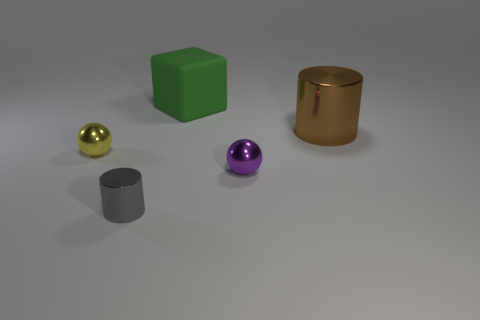Add 3 large yellow balls. How many objects exist? 8 Subtract all blocks. How many objects are left? 4 Subtract all small gray metallic things. Subtract all purple shiny things. How many objects are left? 3 Add 3 tiny cylinders. How many tiny cylinders are left? 4 Add 4 big metal cylinders. How many big metal cylinders exist? 5 Subtract 0 blue cylinders. How many objects are left? 5 Subtract 1 cubes. How many cubes are left? 0 Subtract all brown balls. Subtract all cyan cylinders. How many balls are left? 2 Subtract all yellow cylinders. How many purple spheres are left? 1 